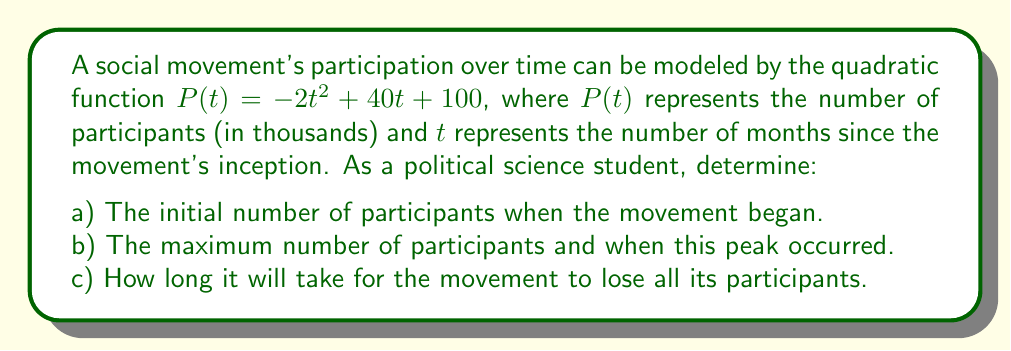Solve this math problem. Let's approach this step-by-step:

a) To find the initial number of participants, we need to evaluate $P(t)$ when $t = 0$:
   $P(0) = -2(0)^2 + 40(0) + 100 = 100$
   This means the movement started with 100,000 participants.

b) To find the maximum number of participants and when it occurred:
   1. The quadratic function $P(t) = -2t^2 + 40t + 100$ is in the form $f(x) = a(x-h)^2 + k$, where $(h,k)$ is the vertex.
   2. For a quadratic function $f(x) = ax^2 + bx + c$, the x-coordinate of the vertex is given by $h = -\frac{b}{2a}$.
   3. In this case, $a = -2$, $b = 40$, so $h = -\frac{40}{2(-2)} = 10$.
   4. To find $k$, we substitute $t = 10$ into the original function:
      $P(10) = -2(10)^2 + 40(10) + 100 = -200 + 400 + 100 = 300$
   5. Therefore, the maximum number of participants is 300,000, occurring at 10 months.

c) To find when the movement loses all participants, we need to solve $P(t) = 0$:
   $-2t^2 + 40t + 100 = 0$
   Using the quadratic formula $\frac{-b \pm \sqrt{b^2 - 4ac}}{2a}$:
   $t = \frac{-40 \pm \sqrt{40^2 - 4(-2)(100)}}{2(-2)}$
   $= \frac{-40 \pm \sqrt{1600 + 800}}{-4}$
   $= \frac{-40 \pm \sqrt{2400}}{-4}$
   $= \frac{-40 \pm 48.99}{-4}$
   This gives us two solutions: $t \approx 22.25$ or $t \approx -2.25$
   Since time cannot be negative in this context, the movement will lose all participants after approximately 22.25 months.
Answer: a) 100,000 participants
b) 300,000 participants at 10 months
c) 22.25 months 